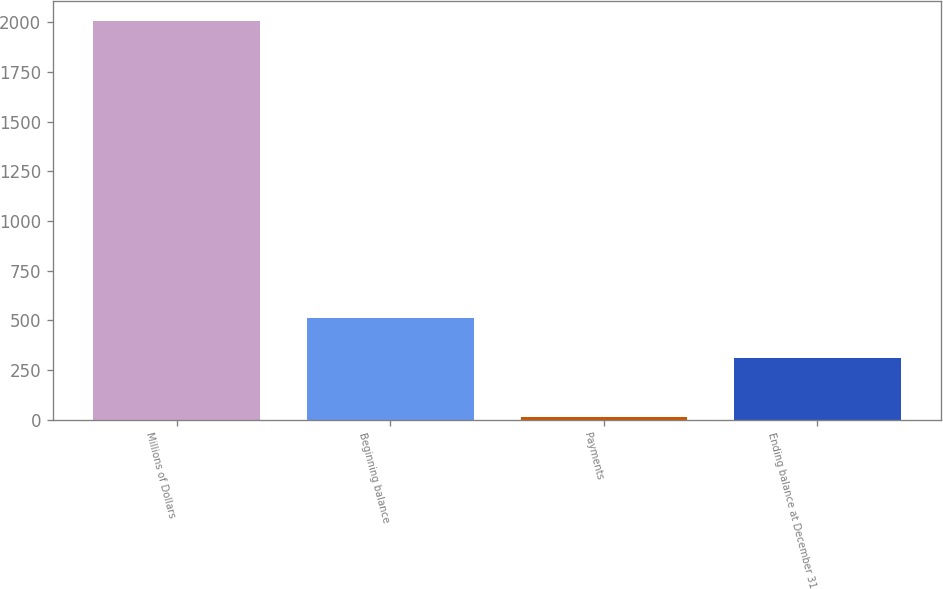Convert chart. <chart><loc_0><loc_0><loc_500><loc_500><bar_chart><fcel>Millions of Dollars<fcel>Beginning balance<fcel>Payments<fcel>Ending balance at December 31<nl><fcel>2005<fcel>510.2<fcel>13<fcel>311<nl></chart> 